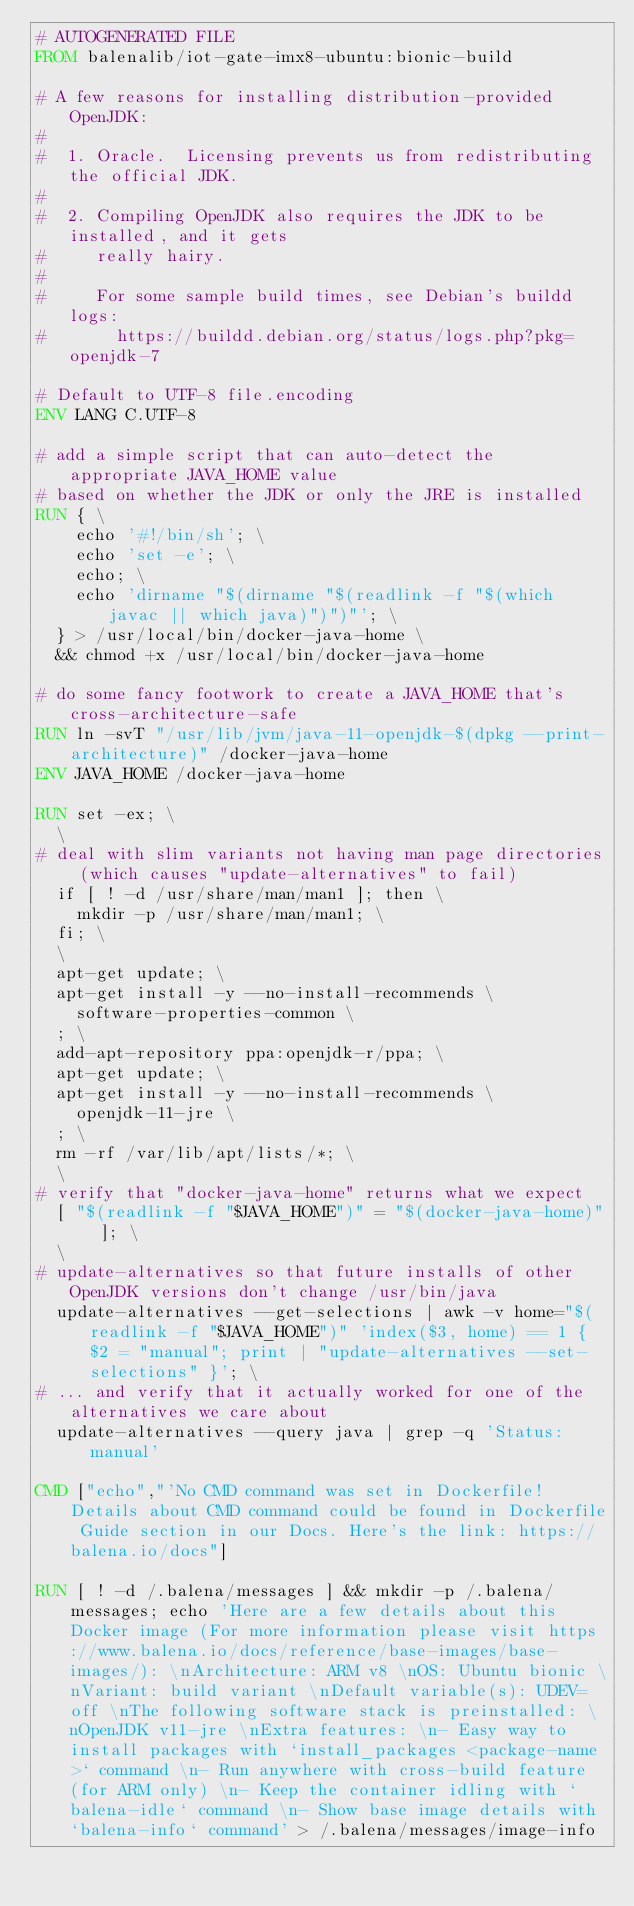Convert code to text. <code><loc_0><loc_0><loc_500><loc_500><_Dockerfile_># AUTOGENERATED FILE
FROM balenalib/iot-gate-imx8-ubuntu:bionic-build

# A few reasons for installing distribution-provided OpenJDK:
#
#  1. Oracle.  Licensing prevents us from redistributing the official JDK.
#
#  2. Compiling OpenJDK also requires the JDK to be installed, and it gets
#     really hairy.
#
#     For some sample build times, see Debian's buildd logs:
#       https://buildd.debian.org/status/logs.php?pkg=openjdk-7

# Default to UTF-8 file.encoding
ENV LANG C.UTF-8

# add a simple script that can auto-detect the appropriate JAVA_HOME value
# based on whether the JDK or only the JRE is installed
RUN { \
		echo '#!/bin/sh'; \
		echo 'set -e'; \
		echo; \
		echo 'dirname "$(dirname "$(readlink -f "$(which javac || which java)")")"'; \
	} > /usr/local/bin/docker-java-home \
	&& chmod +x /usr/local/bin/docker-java-home

# do some fancy footwork to create a JAVA_HOME that's cross-architecture-safe
RUN ln -svT "/usr/lib/jvm/java-11-openjdk-$(dpkg --print-architecture)" /docker-java-home
ENV JAVA_HOME /docker-java-home

RUN set -ex; \
	\
# deal with slim variants not having man page directories (which causes "update-alternatives" to fail)
	if [ ! -d /usr/share/man/man1 ]; then \
		mkdir -p /usr/share/man/man1; \
	fi; \
	\
	apt-get update; \
	apt-get install -y --no-install-recommends \
		software-properties-common \
	; \
	add-apt-repository ppa:openjdk-r/ppa; \
	apt-get update; \
	apt-get install -y --no-install-recommends \
		openjdk-11-jre \
	; \
	rm -rf /var/lib/apt/lists/*; \
	\
# verify that "docker-java-home" returns what we expect
	[ "$(readlink -f "$JAVA_HOME")" = "$(docker-java-home)" ]; \
	\
# update-alternatives so that future installs of other OpenJDK versions don't change /usr/bin/java
	update-alternatives --get-selections | awk -v home="$(readlink -f "$JAVA_HOME")" 'index($3, home) == 1 { $2 = "manual"; print | "update-alternatives --set-selections" }'; \
# ... and verify that it actually worked for one of the alternatives we care about
	update-alternatives --query java | grep -q 'Status: manual'

CMD ["echo","'No CMD command was set in Dockerfile! Details about CMD command could be found in Dockerfile Guide section in our Docs. Here's the link: https://balena.io/docs"]

RUN [ ! -d /.balena/messages ] && mkdir -p /.balena/messages; echo 'Here are a few details about this Docker image (For more information please visit https://www.balena.io/docs/reference/base-images/base-images/): \nArchitecture: ARM v8 \nOS: Ubuntu bionic \nVariant: build variant \nDefault variable(s): UDEV=off \nThe following software stack is preinstalled: \nOpenJDK v11-jre \nExtra features: \n- Easy way to install packages with `install_packages <package-name>` command \n- Run anywhere with cross-build feature  (for ARM only) \n- Keep the container idling with `balena-idle` command \n- Show base image details with `balena-info` command' > /.balena/messages/image-info</code> 